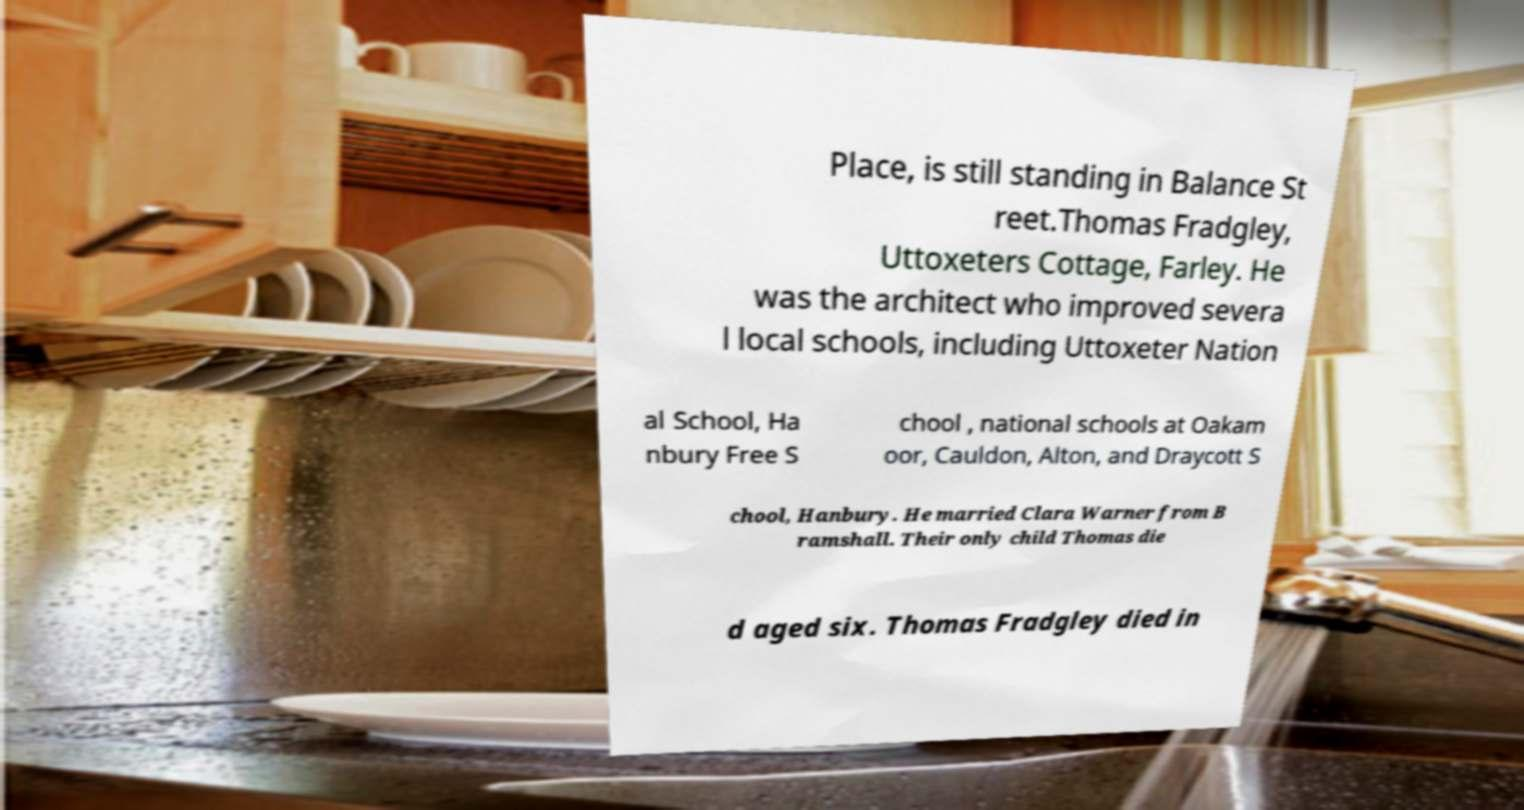Could you assist in decoding the text presented in this image and type it out clearly? Place, is still standing in Balance St reet.Thomas Fradgley, Uttoxeters Cottage, Farley. He was the architect who improved severa l local schools, including Uttoxeter Nation al School, Ha nbury Free S chool , national schools at Oakam oor, Cauldon, Alton, and Draycott S chool, Hanbury. He married Clara Warner from B ramshall. Their only child Thomas die d aged six. Thomas Fradgley died in 